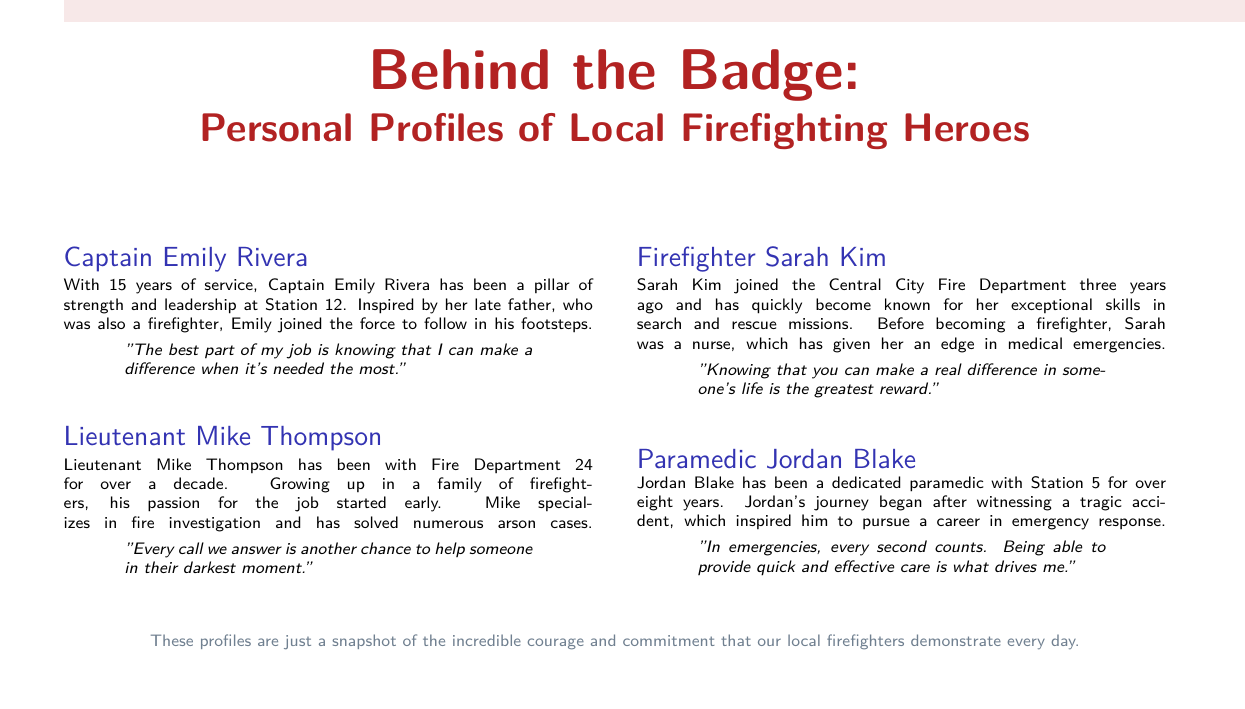What is Captain Emily Rivera's years of service? Captain Emily Rivera has been serving for 15 years, as stated in her block.
Answer: 15 years What is Lieutenant Mike Thompson's area of specialization? The document mentions that Mike specializes in fire investigation.
Answer: fire investigation How long has Firefighter Sarah Kim been with the Central City Fire Department? The document states that Sarah Kim joined three years ago.
Answer: three years What inspired Paramedic Jordan Blake to pursue his career? Jordan's journey began after witnessing a tragic accident, which is mentioned in his profile.
Answer: a tragic accident What quote did Captain Emily Rivera share about her job? The document includes her quote: "The best part of my job is knowing that I can make a difference when it's needed the most."
Answer: "The best part of my job is knowing that I can make a difference when it's needed the most." Which firefighter mentioned having a background in nursing? Sarah Kim's profile indicates that she was a nurse before becoming a firefighter.
Answer: Sarah Kim What color theme is used for the title? The document describes the title color as firered.
Answer: firered What does the final note in the document emphasize? The final note highlights the incredible courage and commitment of local firefighters every day.
Answer: courage and commitment 